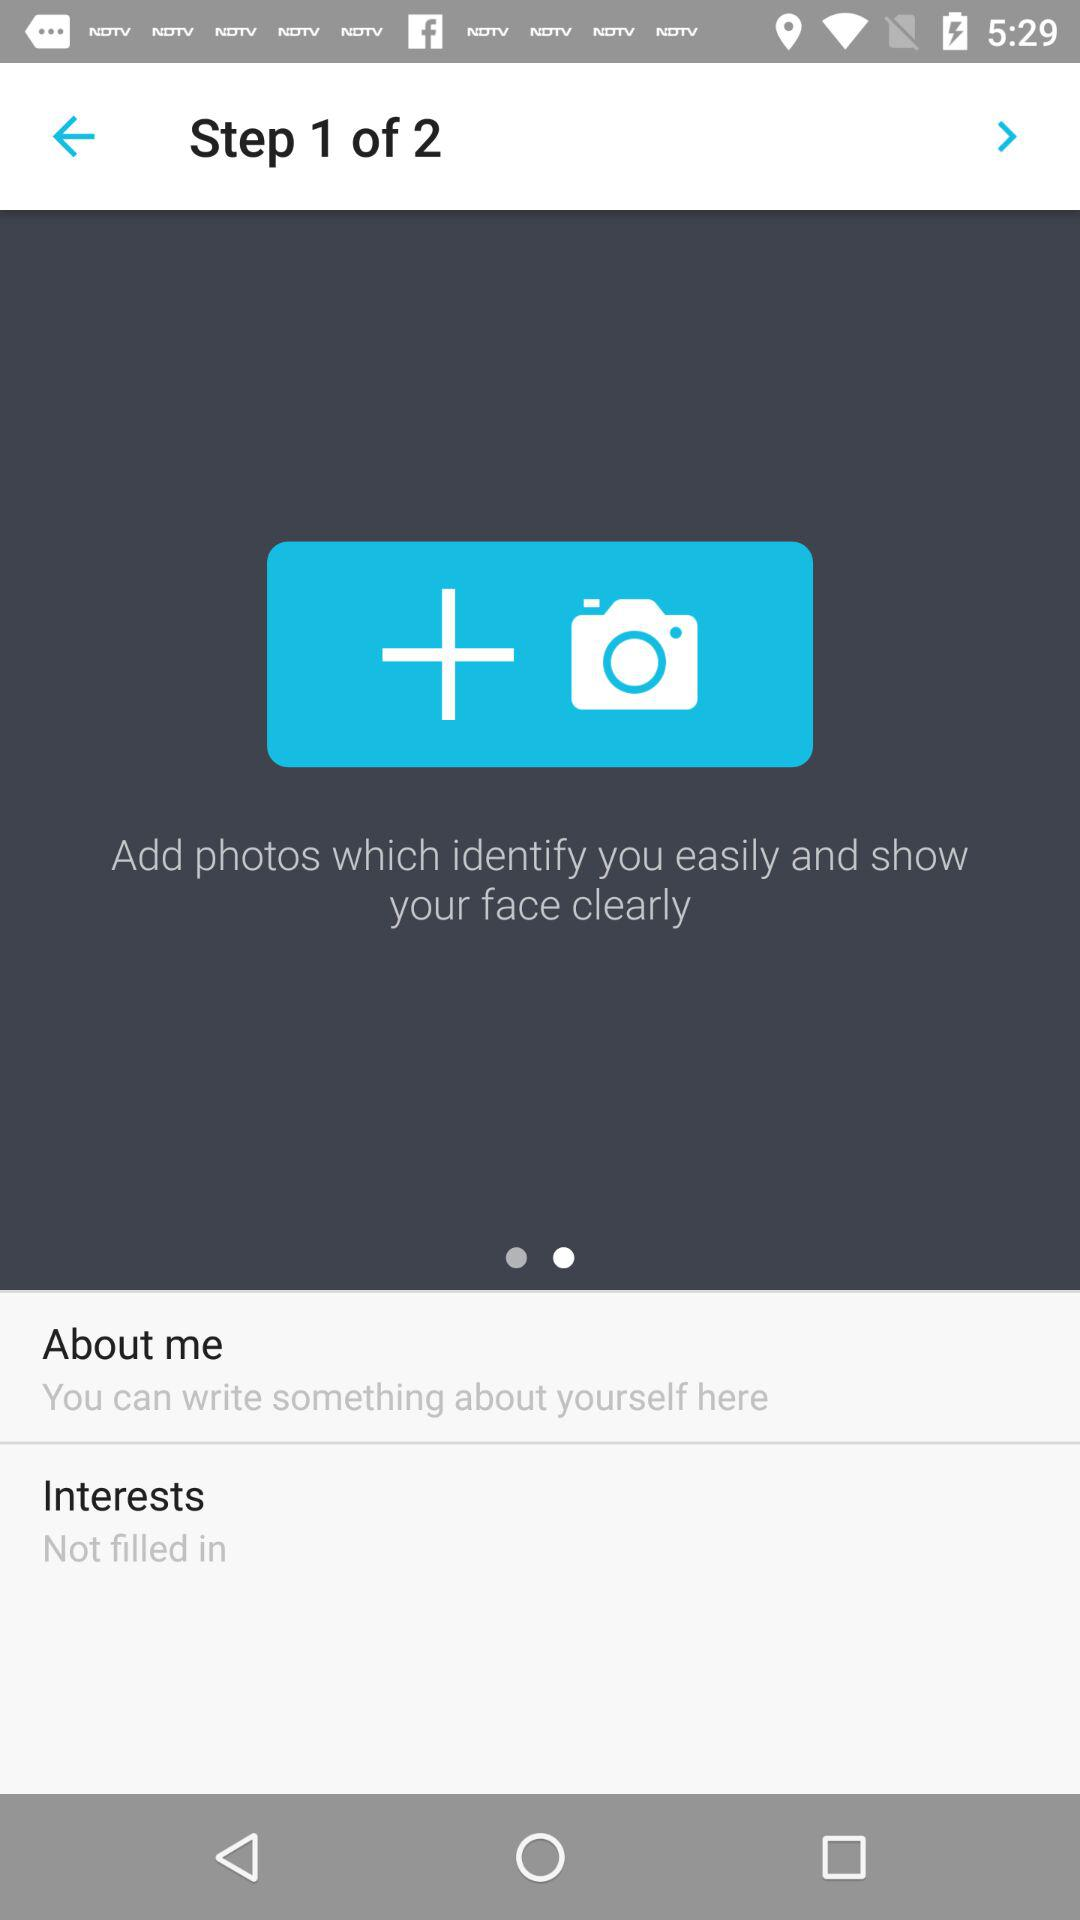How many steps are there in this onboarding process?
Answer the question using a single word or phrase. 2 